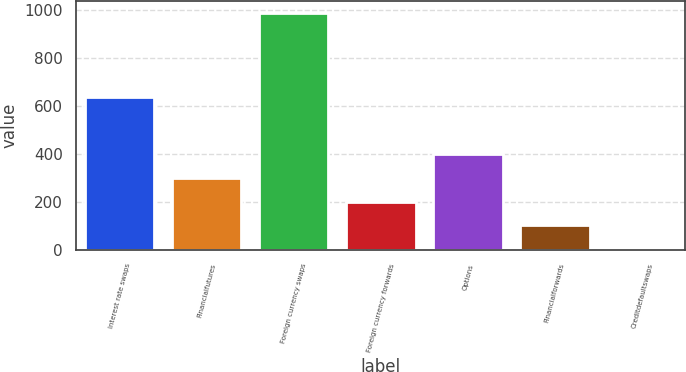<chart> <loc_0><loc_0><loc_500><loc_500><bar_chart><fcel>Interest rate swaps<fcel>Financialfutures<fcel>Foreign currency swaps<fcel>Foreign currency forwards<fcel>Options<fcel>Financialforwards<fcel>Creditdefaultswaps<nl><fcel>639<fcel>299.3<fcel>986<fcel>201.2<fcel>397.4<fcel>103.1<fcel>5<nl></chart> 